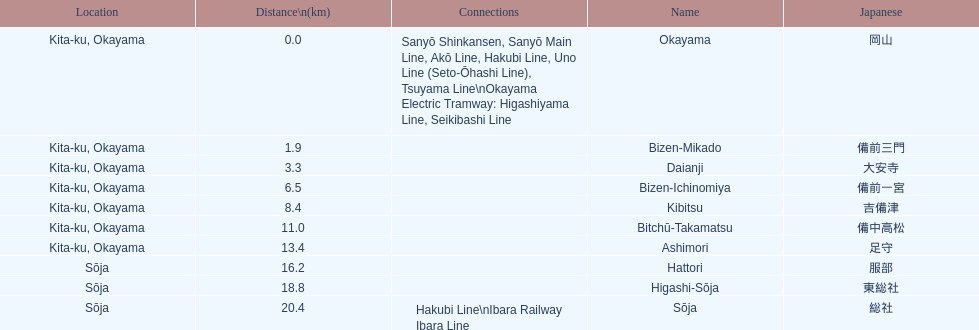Name only the stations that have connections to other lines. Okayama, Sōja. 